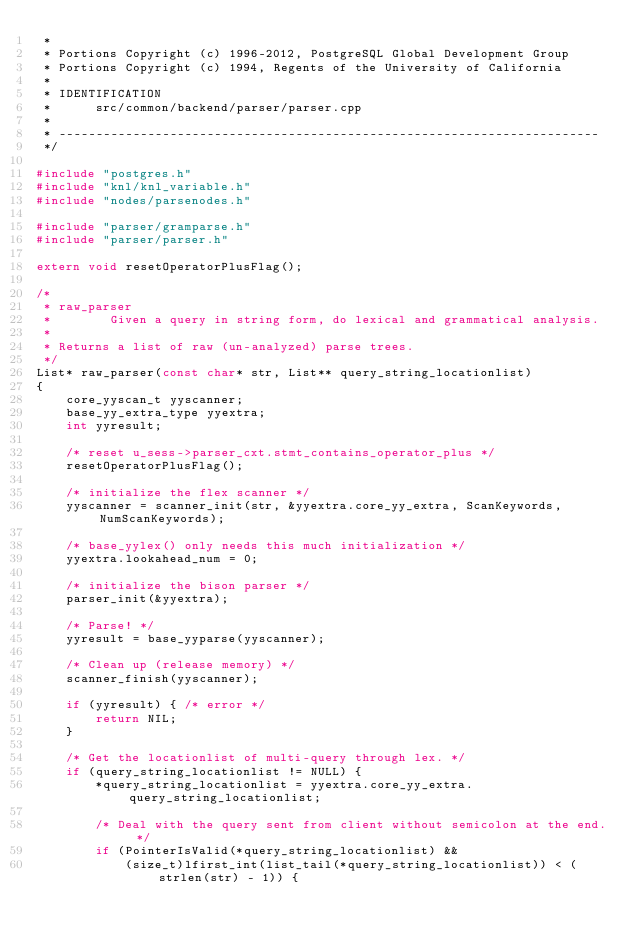<code> <loc_0><loc_0><loc_500><loc_500><_C++_> *
 * Portions Copyright (c) 1996-2012, PostgreSQL Global Development Group
 * Portions Copyright (c) 1994, Regents of the University of California
 *
 * IDENTIFICATION
 *      src/common/backend/parser/parser.cpp
 *
 * -------------------------------------------------------------------------
 */

#include "postgres.h"
#include "knl/knl_variable.h"
#include "nodes/parsenodes.h"

#include "parser/gramparse.h"
#include "parser/parser.h"

extern void resetOperatorPlusFlag();

/*
 * raw_parser
 *        Given a query in string form, do lexical and grammatical analysis.
 *
 * Returns a list of raw (un-analyzed) parse trees.
 */
List* raw_parser(const char* str, List** query_string_locationlist)
{
    core_yyscan_t yyscanner;
    base_yy_extra_type yyextra;
    int yyresult;

    /* reset u_sess->parser_cxt.stmt_contains_operator_plus */
    resetOperatorPlusFlag();

    /* initialize the flex scanner */
    yyscanner = scanner_init(str, &yyextra.core_yy_extra, ScanKeywords, NumScanKeywords);

    /* base_yylex() only needs this much initialization */
    yyextra.lookahead_num = 0;

    /* initialize the bison parser */
    parser_init(&yyextra);

    /* Parse! */
    yyresult = base_yyparse(yyscanner);

    /* Clean up (release memory) */
    scanner_finish(yyscanner);

    if (yyresult) { /* error */
        return NIL;
    }

    /* Get the locationlist of multi-query through lex. */
    if (query_string_locationlist != NULL) {
        *query_string_locationlist = yyextra.core_yy_extra.query_string_locationlist;

        /* Deal with the query sent from client without semicolon at the end. */
        if (PointerIsValid(*query_string_locationlist) &&
            (size_t)lfirst_int(list_tail(*query_string_locationlist)) < (strlen(str) - 1)) {</code> 